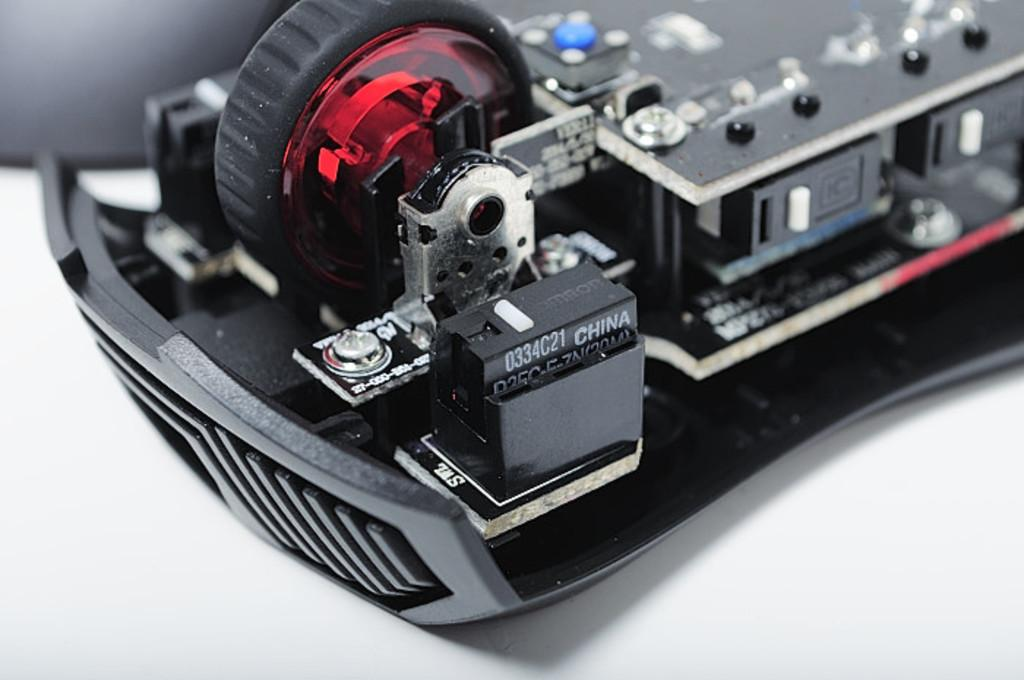What is the main object in the image? There is a machine in the image. What is the color of the surface the machine is on? The machine is on a white surface. What can be seen on the machine itself? There are texts on the machine. How many bears are visible in the image? There are no bears present in the image. What type of fish can be seen swimming near the machine? There are no fish present in the image. 